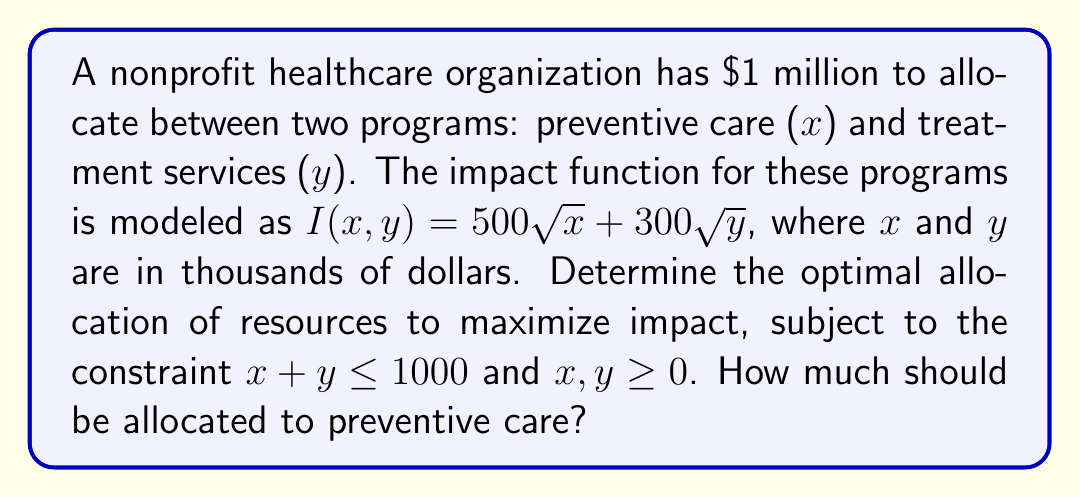Show me your answer to this math problem. To solve this nonlinear programming problem, we'll use the method of Lagrange multipliers:

1) Define the Lagrangian function:
   $$L(x,y,\lambda) = 500\sqrt{x} + 300\sqrt{y} + \lambda(1000 - x - y)$$

2) Calculate partial derivatives and set them to zero:
   $$\frac{\partial L}{\partial x} = \frac{250}{\sqrt{x}} - \lambda = 0$$
   $$\frac{\partial L}{\partial y} = \frac{150}{\sqrt{y}} - \lambda = 0$$
   $$\frac{\partial L}{\partial \lambda} = 1000 - x - y = 0$$

3) From the first two equations:
   $$\frac{250}{\sqrt{x}} = \frac{150}{\sqrt{y}}$$

4) Simplify:
   $$\frac{25}{9} = \frac{x}{y}$$

5) Substitute into the constraint equation:
   $$x + \frac{9x}{25} = 1000$$
   $$\frac{34x}{25} = 1000$$
   $$x = \frac{25000}{34} \approx 735.29$$

6) Check non-negativity constraints:
   Both x and y are positive, satisfying the constraints.

Therefore, the optimal allocation for preventive care (x) is approximately $735,290.
Answer: $735,290 